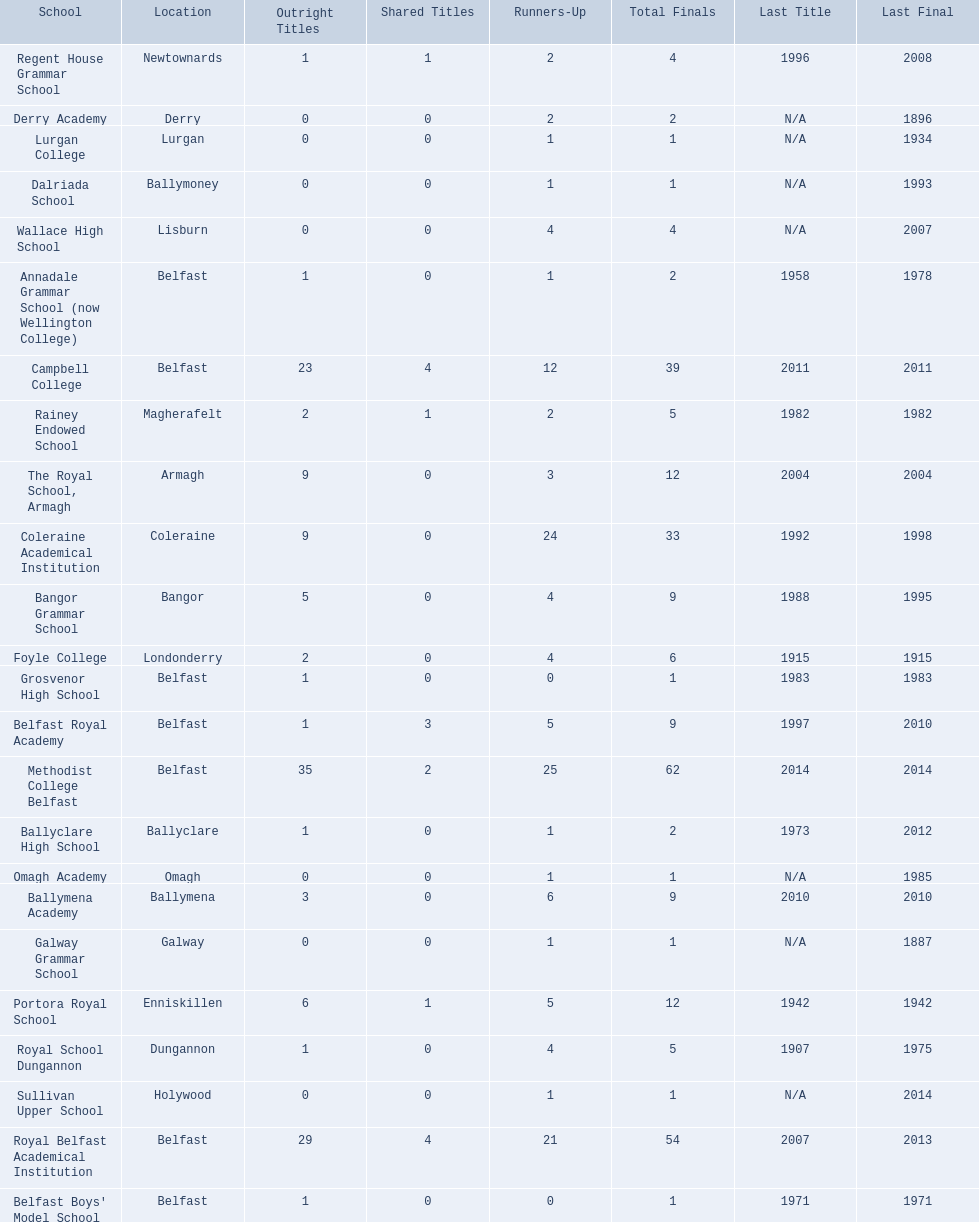What is the most recent win of campbell college? 2011. Parse the table in full. {'header': ['School', 'Location', 'Outright Titles', 'Shared Titles', 'Runners-Up', 'Total Finals', 'Last Title', 'Last Final'], 'rows': [['Regent House Grammar School', 'Newtownards', '1', '1', '2', '4', '1996', '2008'], ['Derry Academy', 'Derry', '0', '0', '2', '2', 'N/A', '1896'], ['Lurgan College', 'Lurgan', '0', '0', '1', '1', 'N/A', '1934'], ['Dalriada School', 'Ballymoney', '0', '0', '1', '1', 'N/A', '1993'], ['Wallace High School', 'Lisburn', '0', '0', '4', '4', 'N/A', '2007'], ['Annadale Grammar School (now Wellington College)', 'Belfast', '1', '0', '1', '2', '1958', '1978'], ['Campbell College', 'Belfast', '23', '4', '12', '39', '2011', '2011'], ['Rainey Endowed School', 'Magherafelt', '2', '1', '2', '5', '1982', '1982'], ['The Royal School, Armagh', 'Armagh', '9', '0', '3', '12', '2004', '2004'], ['Coleraine Academical Institution', 'Coleraine', '9', '0', '24', '33', '1992', '1998'], ['Bangor Grammar School', 'Bangor', '5', '0', '4', '9', '1988', '1995'], ['Foyle College', 'Londonderry', '2', '0', '4', '6', '1915', '1915'], ['Grosvenor High School', 'Belfast', '1', '0', '0', '1', '1983', '1983'], ['Belfast Royal Academy', 'Belfast', '1', '3', '5', '9', '1997', '2010'], ['Methodist College Belfast', 'Belfast', '35', '2', '25', '62', '2014', '2014'], ['Ballyclare High School', 'Ballyclare', '1', '0', '1', '2', '1973', '2012'], ['Omagh Academy', 'Omagh', '0', '0', '1', '1', 'N/A', '1985'], ['Ballymena Academy', 'Ballymena', '3', '0', '6', '9', '2010', '2010'], ['Galway Grammar School', 'Galway', '0', '0', '1', '1', 'N/A', '1887'], ['Portora Royal School', 'Enniskillen', '6', '1', '5', '12', '1942', '1942'], ['Royal School Dungannon', 'Dungannon', '1', '0', '4', '5', '1907', '1975'], ['Sullivan Upper School', 'Holywood', '0', '0', '1', '1', 'N/A', '2014'], ['Royal Belfast Academical Institution', 'Belfast', '29', '4', '21', '54', '2007', '2013'], ["Belfast Boys' Model School", 'Belfast', '1', '0', '0', '1', '1971', '1971']]} What is the most recent win of regent house grammar school? 1996. Which date is more recent? 2011. What is the name of the school with this date? Campbell College. 